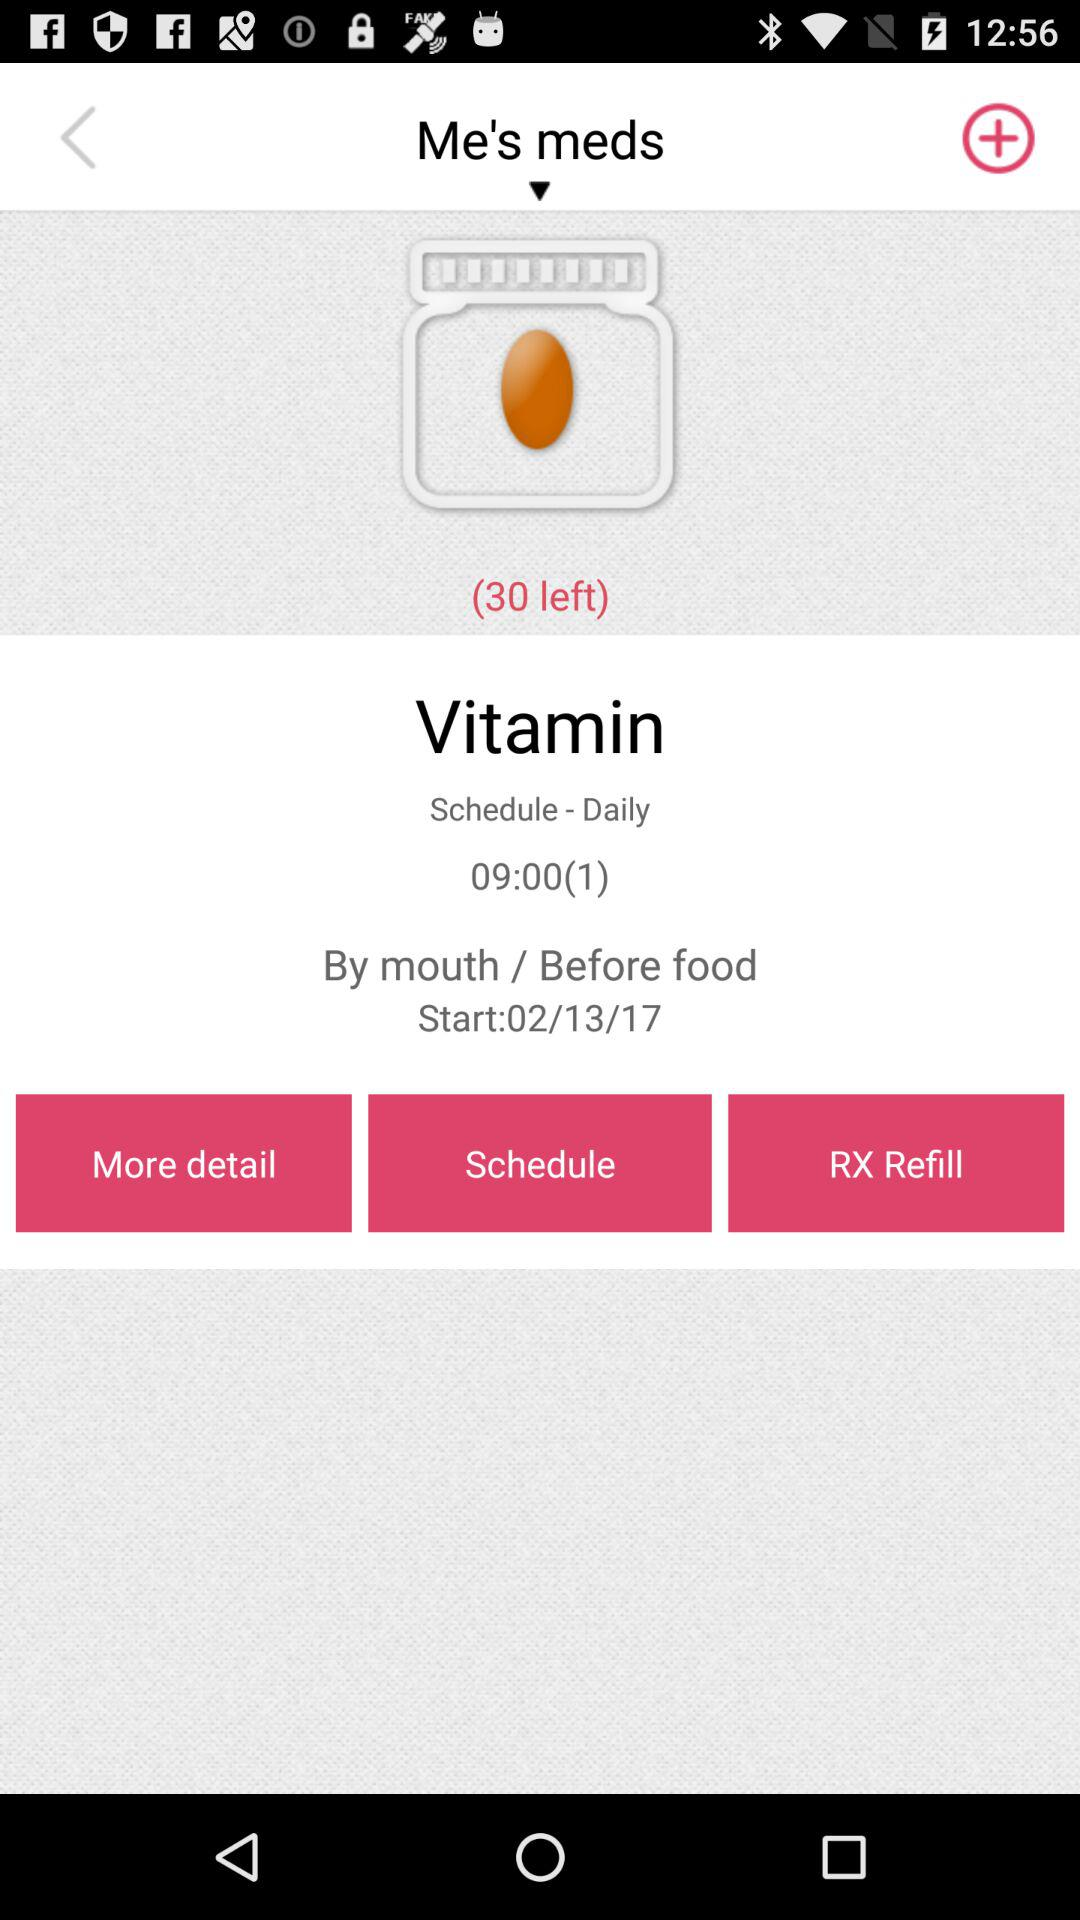How many pills are left in the bottle?
Answer the question using a single word or phrase. 30 